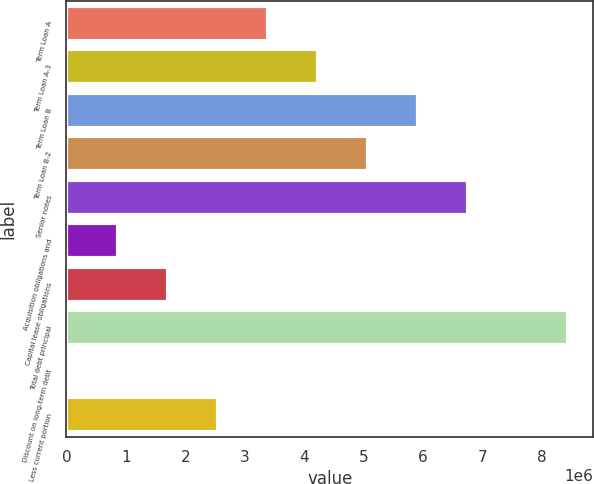<chart> <loc_0><loc_0><loc_500><loc_500><bar_chart><fcel>Term Loan A<fcel>Term Loan A-3<fcel>Term Loan B<fcel>Term Loan B-2<fcel>Senior notes<fcel>Acquisition obligations and<fcel>Capital lease obligations<fcel>Total debt principal<fcel>Discount on long-term debt<fcel>Less current portion<nl><fcel>3.38405e+06<fcel>4.22564e+06<fcel>5.90882e+06<fcel>5.06723e+06<fcel>6.75042e+06<fcel>859268<fcel>1.70086e+06<fcel>8.4336e+06<fcel>17675<fcel>2.54245e+06<nl></chart> 